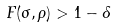<formula> <loc_0><loc_0><loc_500><loc_500>F ( \sigma , \rho ) > 1 - \delta</formula> 